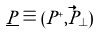<formula> <loc_0><loc_0><loc_500><loc_500>\underline { P } \equiv ( P ^ { + } , \vec { P } _ { \perp } )</formula> 